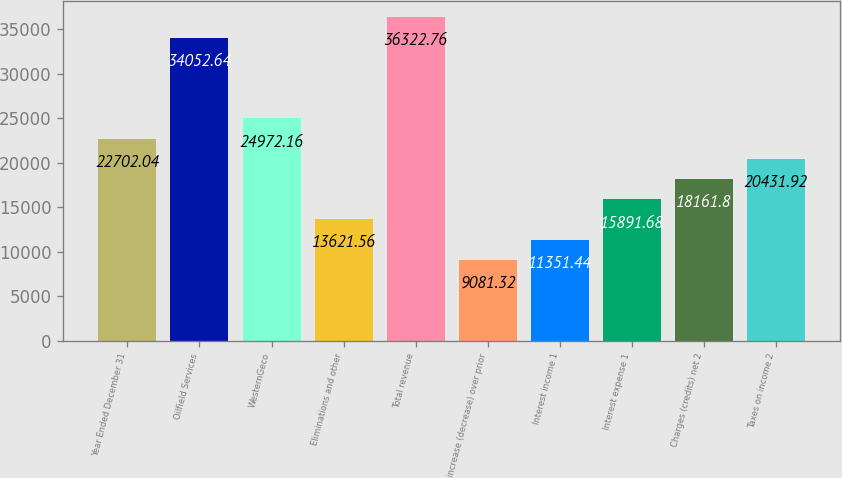Convert chart. <chart><loc_0><loc_0><loc_500><loc_500><bar_chart><fcel>Year Ended December 31<fcel>Oilfield Services<fcel>WesternGeco<fcel>Eliminations and other<fcel>Total revenue<fcel>increase (decrease) over prior<fcel>Interest income 1<fcel>Interest expense 1<fcel>Charges (credits) net 2<fcel>Taxes on income 2<nl><fcel>22702<fcel>34052.6<fcel>24972.2<fcel>13621.6<fcel>36322.8<fcel>9081.32<fcel>11351.4<fcel>15891.7<fcel>18161.8<fcel>20431.9<nl></chart> 